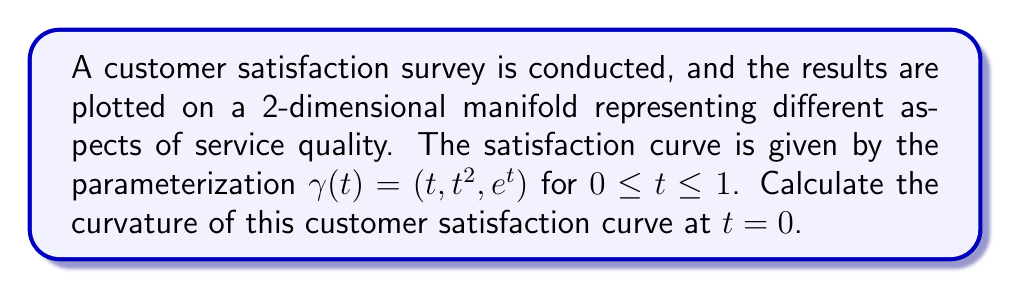Teach me how to tackle this problem. To calculate the curvature of the customer satisfaction curve on the manifold, we'll follow these steps:

1) The curvature $\kappa$ of a curve $\gamma(t)$ on a manifold is given by:

   $$\kappa = \frac{|\gamma'(t) \times \gamma''(t)|}{|\gamma'(t)|^3}$$

2) First, let's calculate $\gamma'(t)$ and $\gamma''(t)$:

   $\gamma'(t) = (1, 2t, e^t)$
   $\gamma''(t) = (0, 2, e^t)$

3) At $t = 0$:

   $\gamma'(0) = (1, 0, 1)$
   $\gamma''(0) = (0, 2, 1)$

4) Now, let's calculate the cross product $\gamma'(0) \times \gamma''(0)$:

   $$\gamma'(0) \times \gamma''(0) = \begin{vmatrix}
   \mathbf{i} & \mathbf{j} & \mathbf{k} \\
   1 & 0 & 1 \\
   0 & 2 & 1
   \end{vmatrix} = (2, -1, 2)$$

5) The magnitude of this cross product is:

   $|\gamma'(0) \times \gamma''(0)| = \sqrt{2^2 + (-1)^2 + 2^2} = 3$

6) The magnitude of $\gamma'(0)$ is:

   $|\gamma'(0)| = \sqrt{1^2 + 0^2 + 1^2} = \sqrt{2}$

7) Now we can calculate the curvature:

   $$\kappa = \frac{|\gamma'(0) \times \gamma''(0)|}{|\gamma'(0)|^3} = \frac{3}{(\sqrt{2})^3} = \frac{3}{2\sqrt{2}}$$
Answer: The curvature of the customer satisfaction curve at $t = 0$ is $\frac{3}{2\sqrt{2}}$. 